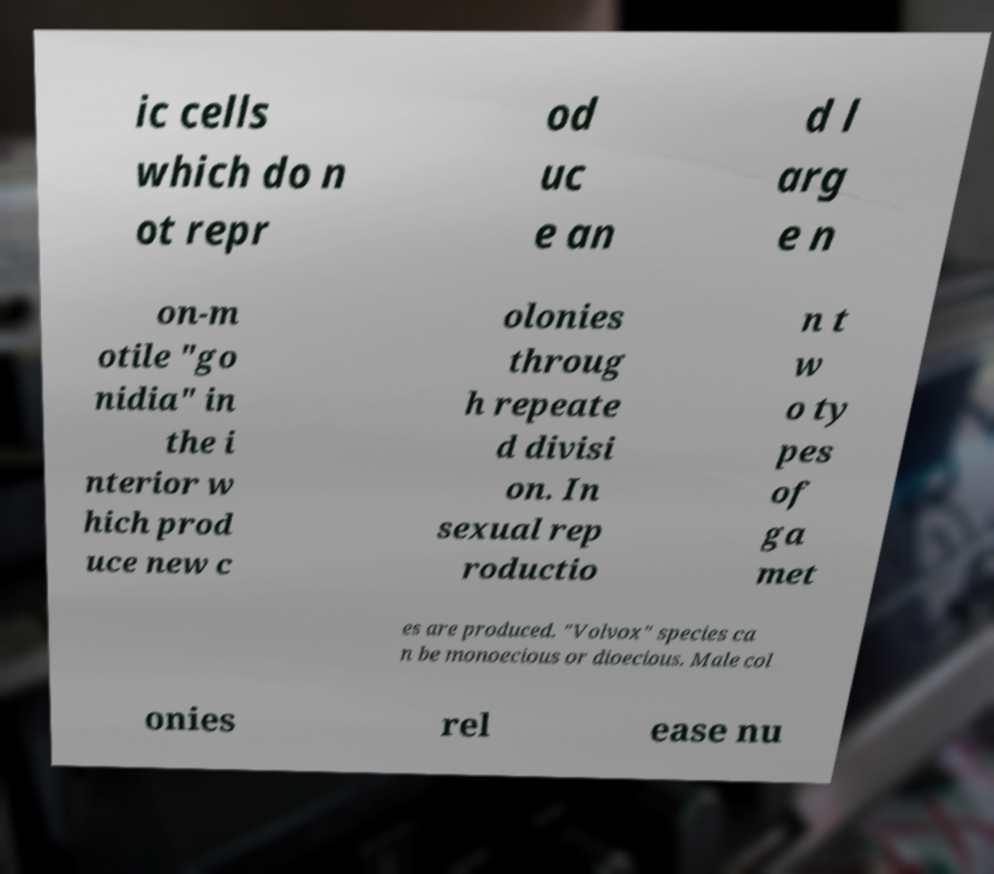Can you read and provide the text displayed in the image?This photo seems to have some interesting text. Can you extract and type it out for me? ic cells which do n ot repr od uc e an d l arg e n on-m otile "go nidia" in the i nterior w hich prod uce new c olonies throug h repeate d divisi on. In sexual rep roductio n t w o ty pes of ga met es are produced. "Volvox" species ca n be monoecious or dioecious. Male col onies rel ease nu 